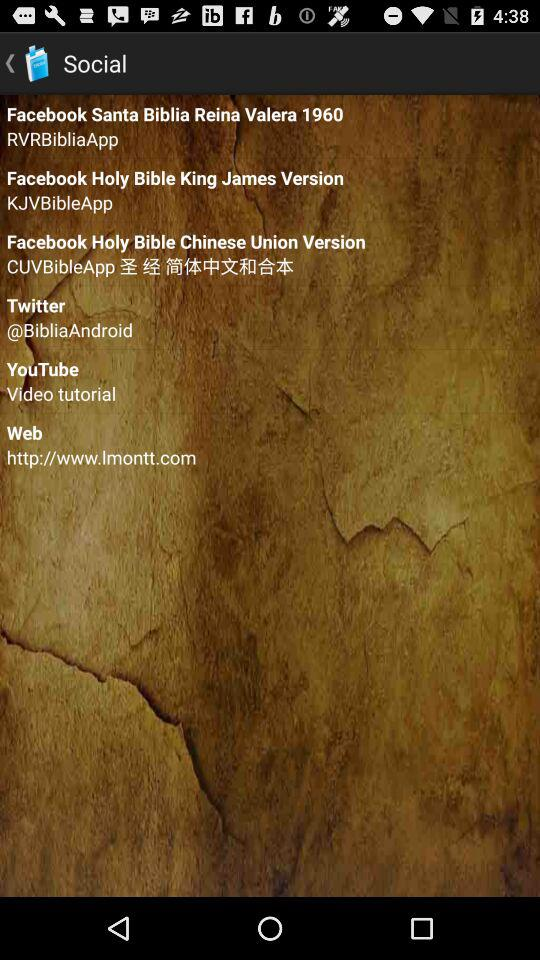What is the website link? The website link is http://www.Imontt.com. 